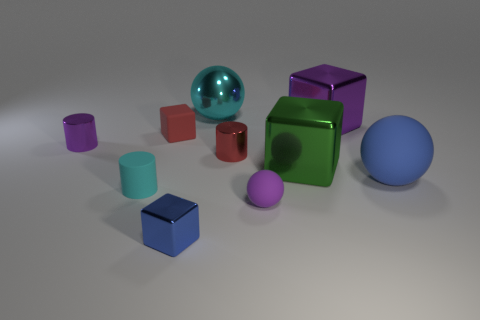How big is the cylinder that is on the left side of the red cylinder and behind the big green metallic block?
Provide a succinct answer. Small. There is a blue rubber thing; what shape is it?
Ensure brevity in your answer.  Sphere. Is there a blue shiny thing that is left of the metal cylinder that is to the left of the blue metal block?
Your answer should be compact. No. What is the material of the red cylinder that is the same size as the matte cube?
Ensure brevity in your answer.  Metal. Is there another green metal cube that has the same size as the green shiny block?
Keep it short and to the point. No. There is a small red object that is on the right side of the small blue shiny block; what material is it?
Provide a short and direct response. Metal. Does the small purple object on the left side of the big shiny sphere have the same material as the large blue sphere?
Offer a very short reply. No. The blue metallic thing that is the same size as the matte cylinder is what shape?
Ensure brevity in your answer.  Cube. What number of big objects are the same color as the small metal block?
Your response must be concise. 1. Is the number of large green shiny objects behind the big green block less than the number of rubber cubes to the left of the rubber cube?
Offer a terse response. No. 